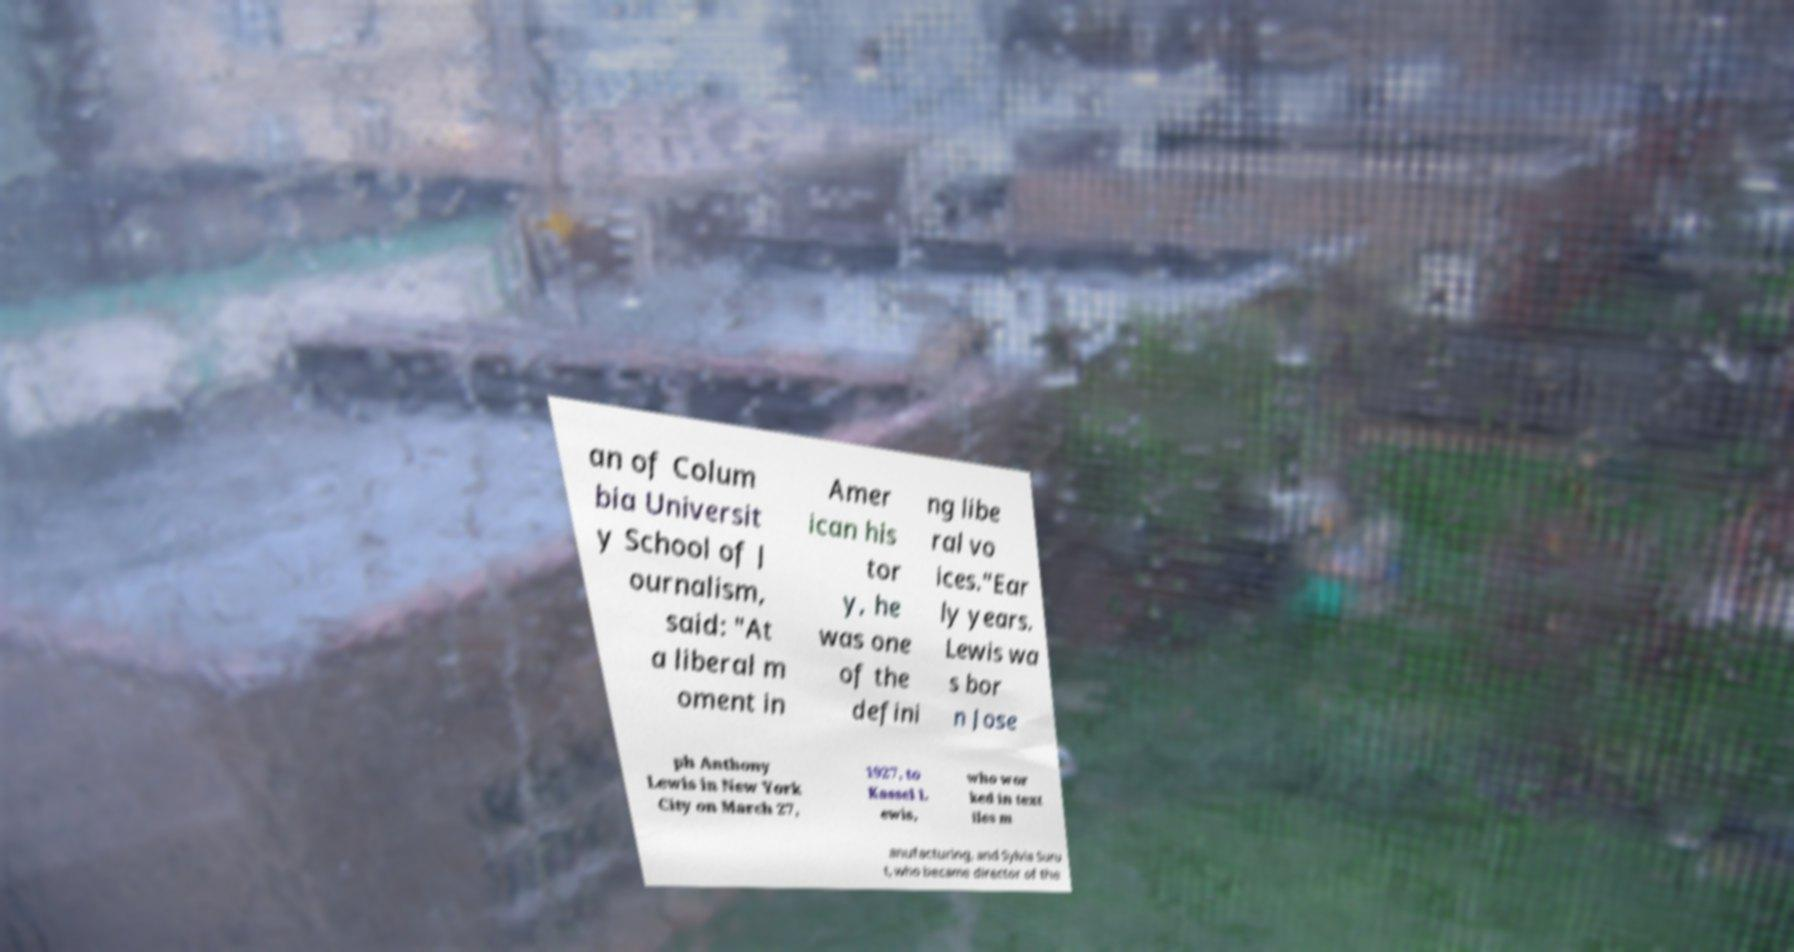Please read and relay the text visible in this image. What does it say? an of Colum bia Universit y School of J ournalism, said: "At a liberal m oment in Amer ican his tor y, he was one of the defini ng libe ral vo ices."Ear ly years. Lewis wa s bor n Jose ph Anthony Lewis in New York City on March 27, 1927, to Kassel L ewis, who wor ked in text iles m anufacturing, and Sylvia Suru t, who became director of the 